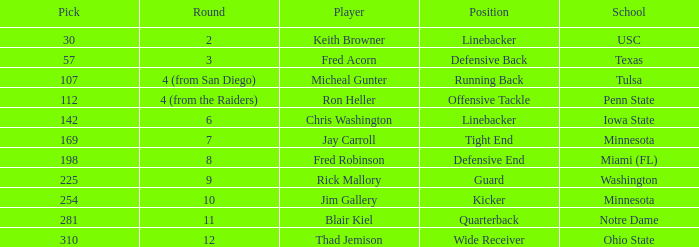What is the total pick number from round 2? 1.0. Parse the table in full. {'header': ['Pick', 'Round', 'Player', 'Position', 'School'], 'rows': [['30', '2', 'Keith Browner', 'Linebacker', 'USC'], ['57', '3', 'Fred Acorn', 'Defensive Back', 'Texas'], ['107', '4 (from San Diego)', 'Micheal Gunter', 'Running Back', 'Tulsa'], ['112', '4 (from the Raiders)', 'Ron Heller', 'Offensive Tackle', 'Penn State'], ['142', '6', 'Chris Washington', 'Linebacker', 'Iowa State'], ['169', '7', 'Jay Carroll', 'Tight End', 'Minnesota'], ['198', '8', 'Fred Robinson', 'Defensive End', 'Miami (FL)'], ['225', '9', 'Rick Mallory', 'Guard', 'Washington'], ['254', '10', 'Jim Gallery', 'Kicker', 'Minnesota'], ['281', '11', 'Blair Kiel', 'Quarterback', 'Notre Dame'], ['310', '12', 'Thad Jemison', 'Wide Receiver', 'Ohio State']]} 